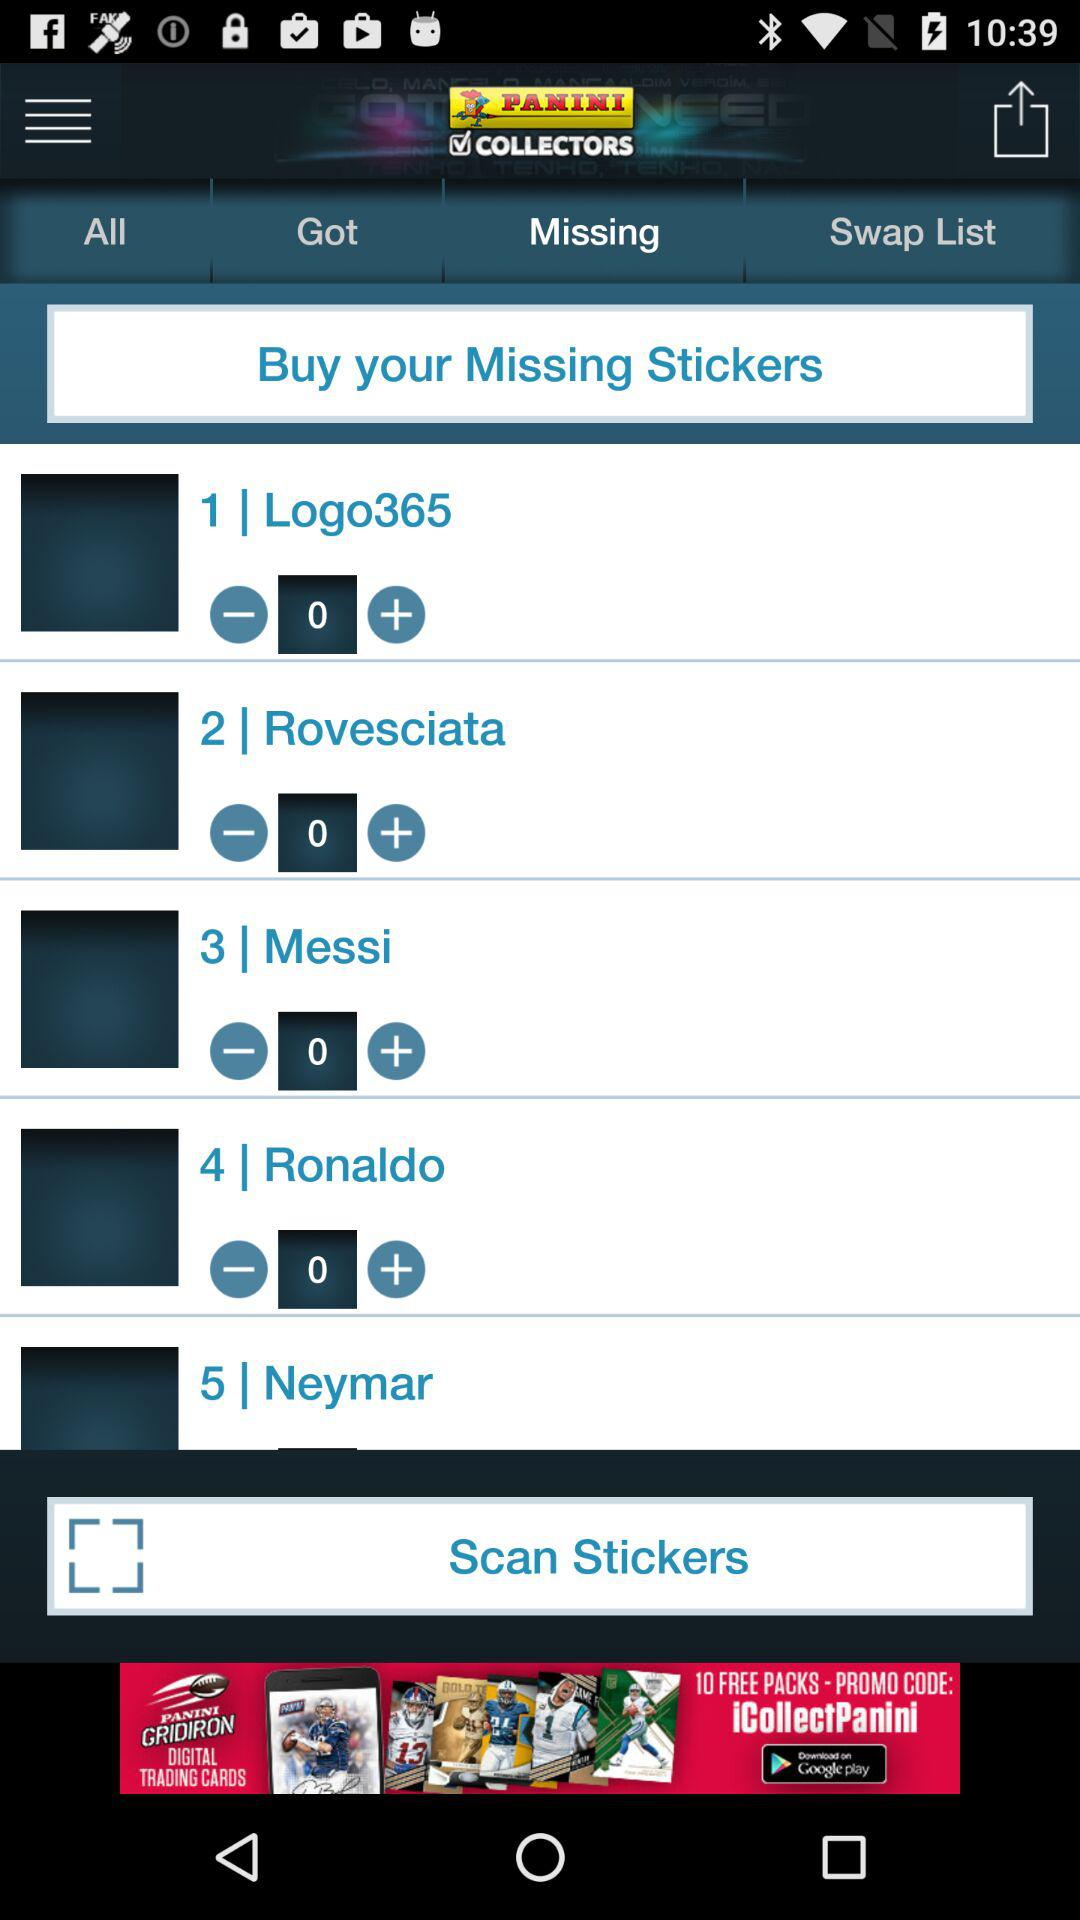What is the serial number for Messi? The serial number for Messi is 3. 